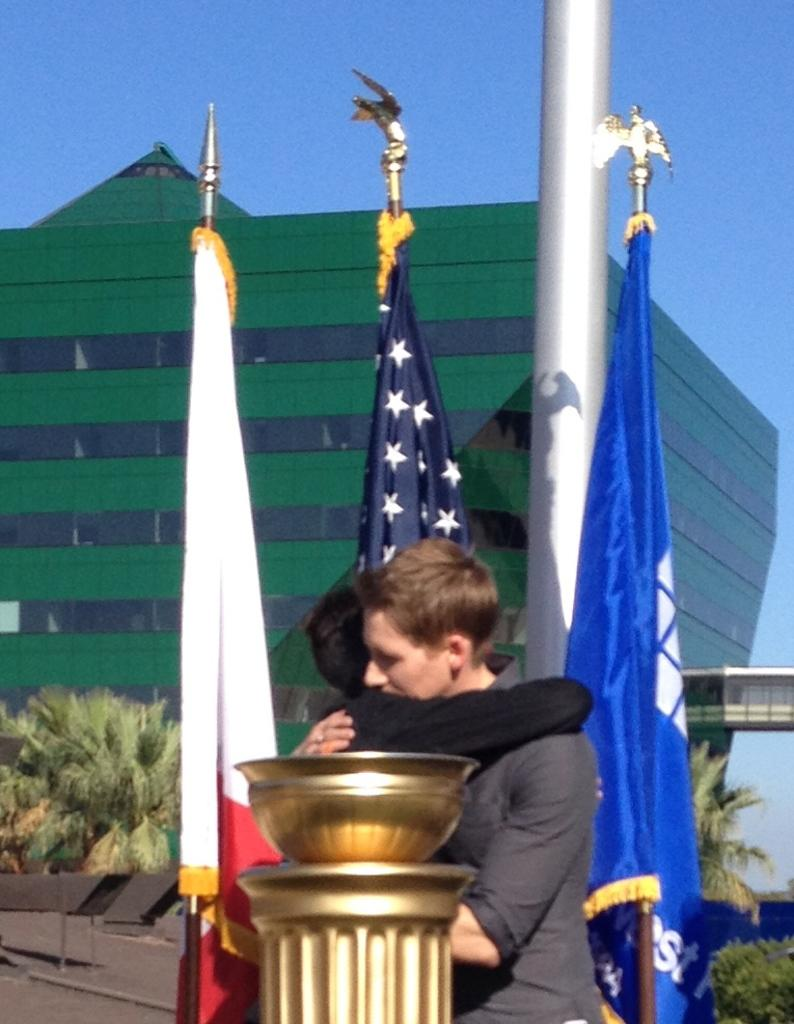Who or what is present in the image? There are people in the image. What can be seen in addition to the people? There are flags visible in the image. Can you describe any objects or structures in the image? There is a pole in the image. What can be seen in the background of the image? There are trees and a building in the background of the image. What type of book is being read by the insect in the image? There is no insect or book present in the image. 